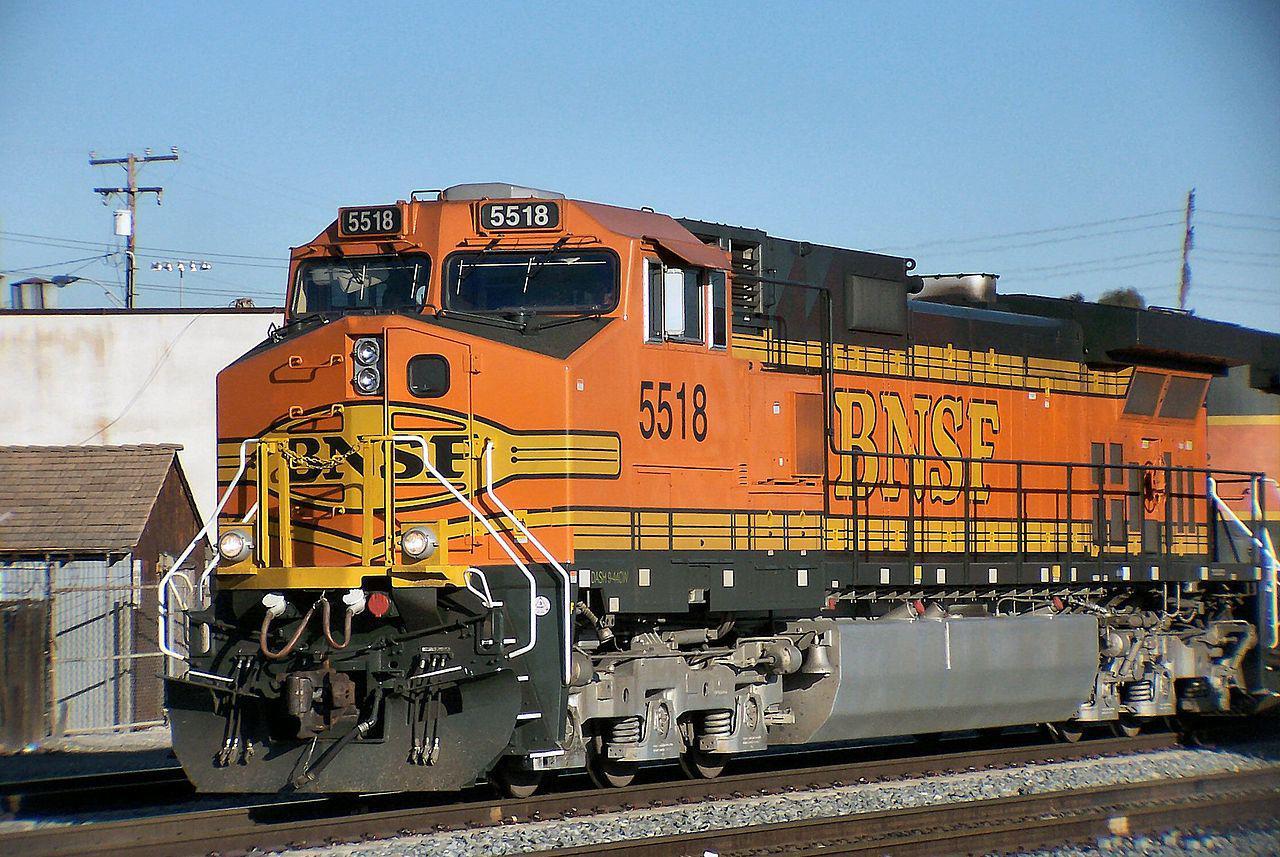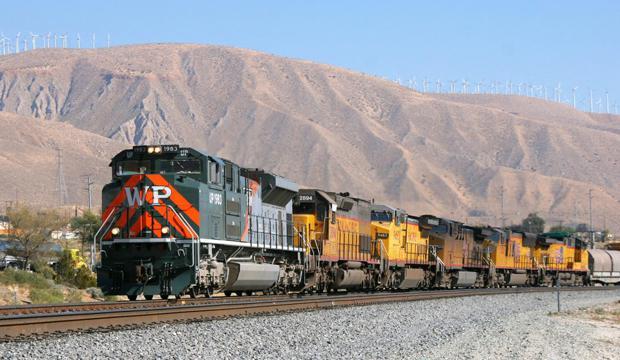The first image is the image on the left, the second image is the image on the right. Evaluate the accuracy of this statement regarding the images: "In one image, an orange and yellow locomotive has steps and white hand rails leading to a small yellow platform.". Is it true? Answer yes or no. Yes. The first image is the image on the left, the second image is the image on the right. Analyze the images presented: Is the assertion "The trains in the left and right images appear to be headed toward each other, so they would collide." valid? Answer yes or no. No. 